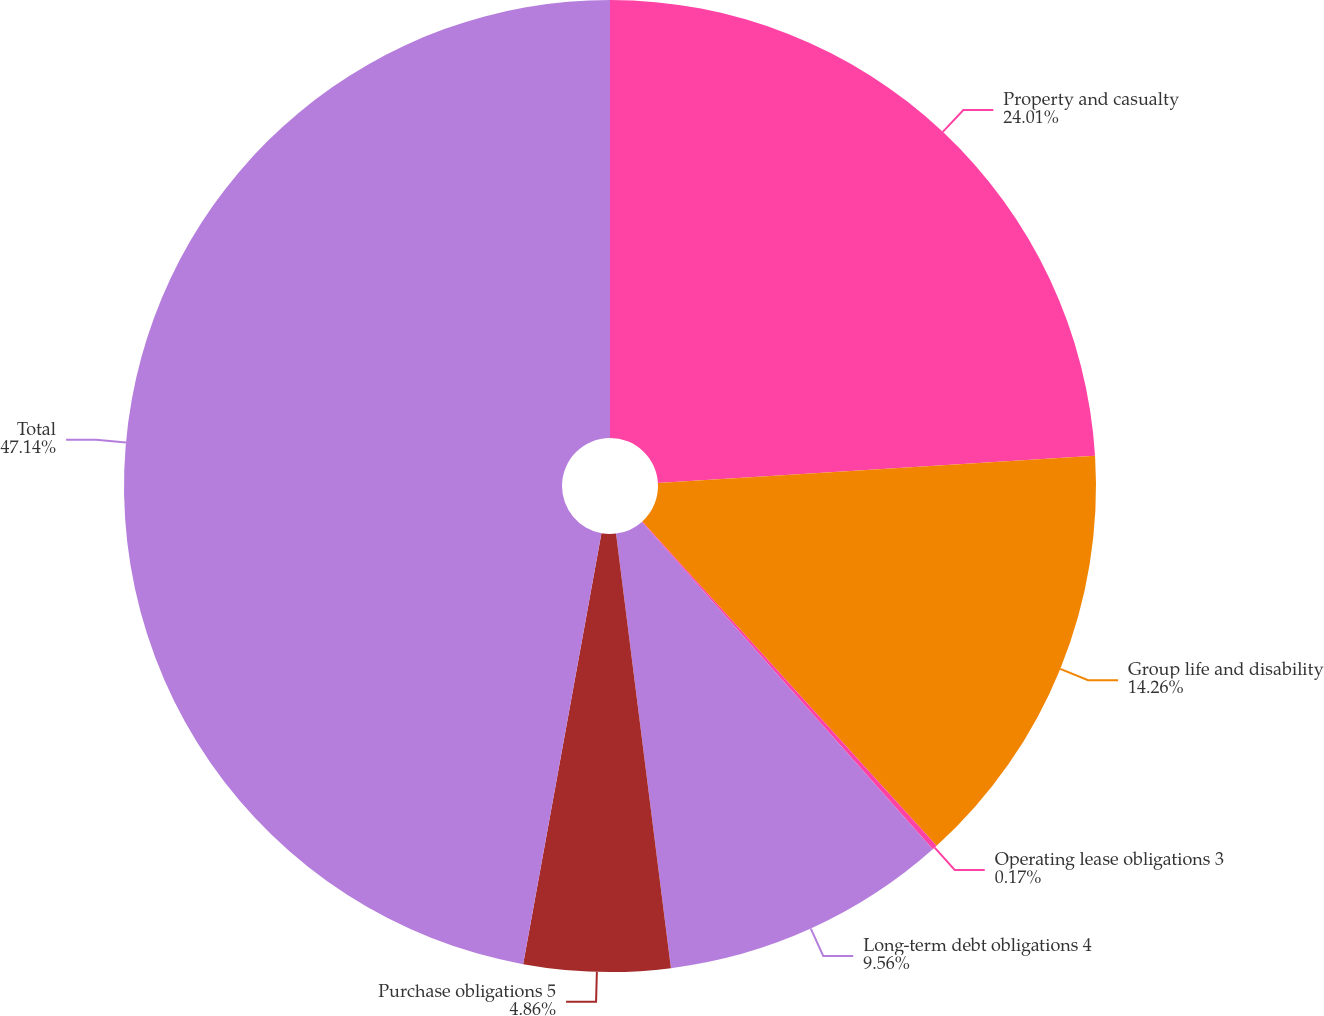Convert chart. <chart><loc_0><loc_0><loc_500><loc_500><pie_chart><fcel>Property and casualty<fcel>Group life and disability<fcel>Operating lease obligations 3<fcel>Long-term debt obligations 4<fcel>Purchase obligations 5<fcel>Total<nl><fcel>24.01%<fcel>14.26%<fcel>0.17%<fcel>9.56%<fcel>4.86%<fcel>47.14%<nl></chart> 